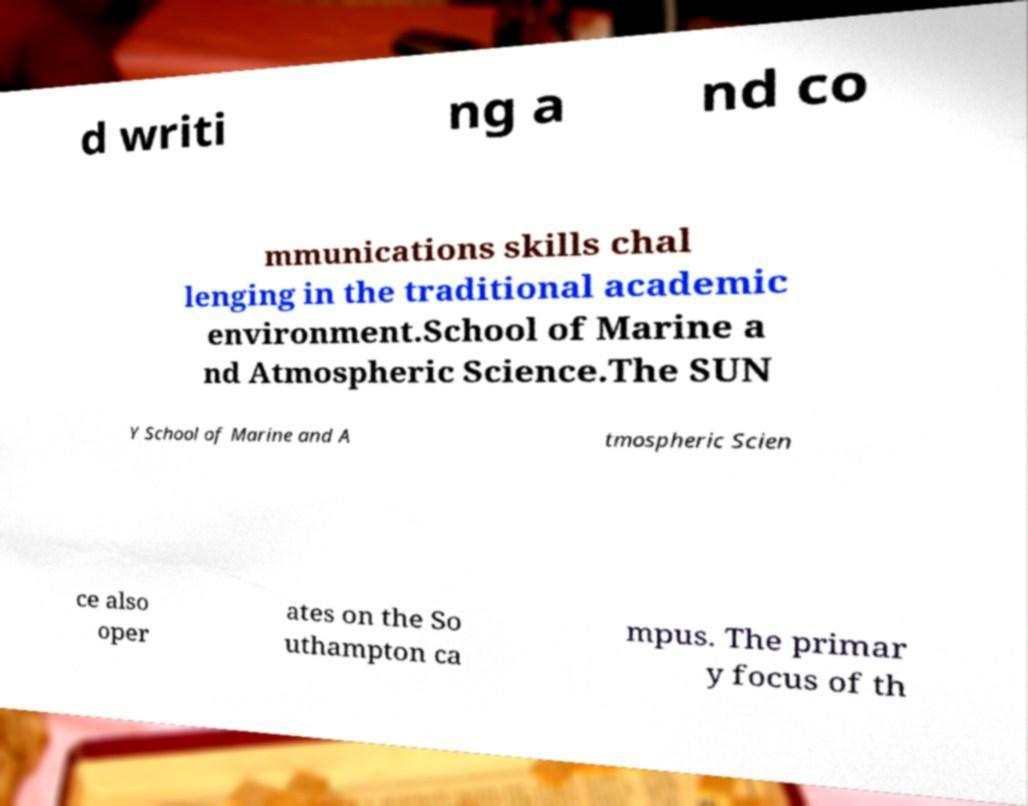I need the written content from this picture converted into text. Can you do that? d writi ng a nd co mmunications skills chal lenging in the traditional academic environment.School of Marine a nd Atmospheric Science.The SUN Y School of Marine and A tmospheric Scien ce also oper ates on the So uthampton ca mpus. The primar y focus of th 